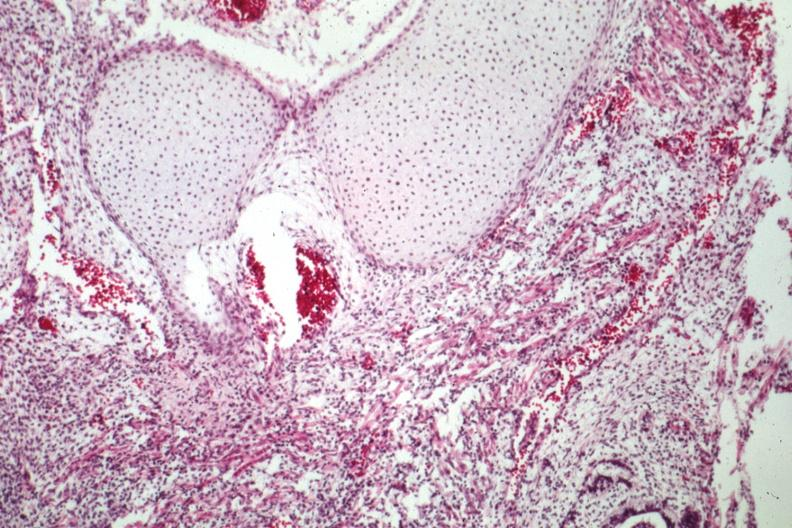s sacrococcygeal teratoma present?
Answer the question using a single word or phrase. Yes 